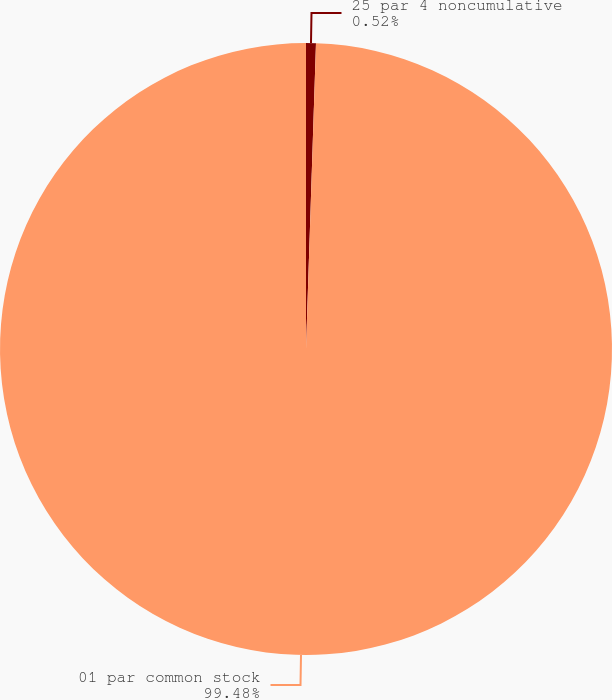Convert chart to OTSL. <chart><loc_0><loc_0><loc_500><loc_500><pie_chart><fcel>25 par 4 noncumulative<fcel>01 par common stock<nl><fcel>0.52%<fcel>99.48%<nl></chart> 